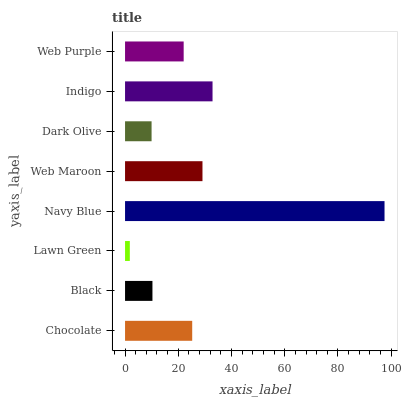Is Lawn Green the minimum?
Answer yes or no. Yes. Is Navy Blue the maximum?
Answer yes or no. Yes. Is Black the minimum?
Answer yes or no. No. Is Black the maximum?
Answer yes or no. No. Is Chocolate greater than Black?
Answer yes or no. Yes. Is Black less than Chocolate?
Answer yes or no. Yes. Is Black greater than Chocolate?
Answer yes or no. No. Is Chocolate less than Black?
Answer yes or no. No. Is Chocolate the high median?
Answer yes or no. Yes. Is Web Purple the low median?
Answer yes or no. Yes. Is Dark Olive the high median?
Answer yes or no. No. Is Dark Olive the low median?
Answer yes or no. No. 